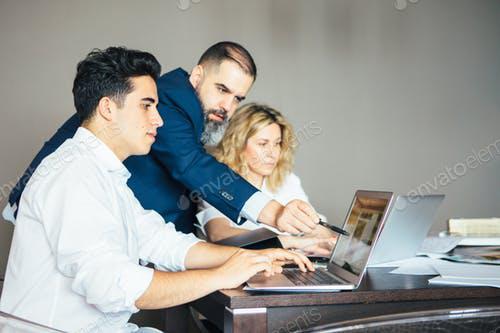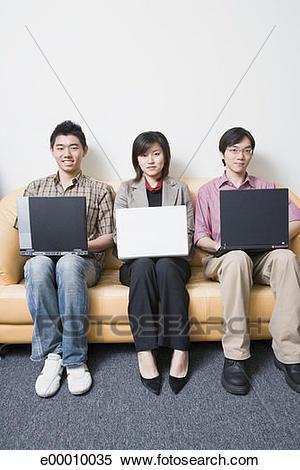The first image is the image on the left, the second image is the image on the right. Evaluate the accuracy of this statement regarding the images: "One image shows a row of three young women sitting behind one open laptop, and the other image shows a baby boy with a hand on the keyboard of an open laptop.". Is it true? Answer yes or no. No. The first image is the image on the left, the second image is the image on the right. Considering the images on both sides, is "In one photo, a young child interacts with a laptop and in the other photo, three women look at a single laptop." valid? Answer yes or no. No. 